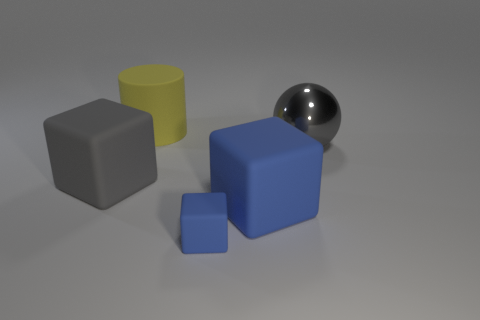Subtract all gray cubes. How many cubes are left? 2 Subtract all blue cubes. How many cubes are left? 1 Subtract all cylinders. How many objects are left? 4 Subtract all cyan balls. How many blue cubes are left? 2 Subtract 1 cubes. How many cubes are left? 2 Add 3 yellow rubber objects. How many objects exist? 8 Subtract all green cubes. Subtract all cyan cylinders. How many cubes are left? 3 Subtract all large spheres. Subtract all yellow matte blocks. How many objects are left? 4 Add 5 tiny rubber objects. How many tiny rubber objects are left? 6 Add 1 big cylinders. How many big cylinders exist? 2 